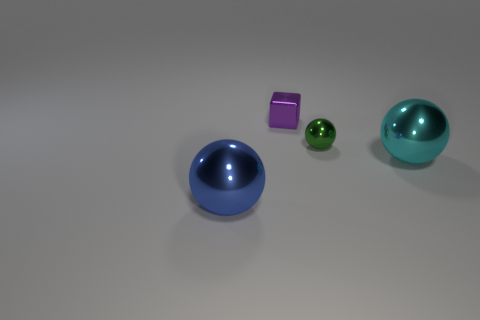Subtract all large cyan spheres. How many spheres are left? 2 Add 4 green metallic things. How many objects exist? 8 Subtract all green balls. How many balls are left? 2 Subtract all spheres. How many objects are left? 1 Subtract 2 balls. How many balls are left? 1 Subtract all big blue rubber cylinders. Subtract all cyan balls. How many objects are left? 3 Add 1 cyan metallic objects. How many cyan metallic objects are left? 2 Add 4 small blue shiny cubes. How many small blue shiny cubes exist? 4 Subtract 0 gray cubes. How many objects are left? 4 Subtract all purple spheres. Subtract all red cylinders. How many spheres are left? 3 